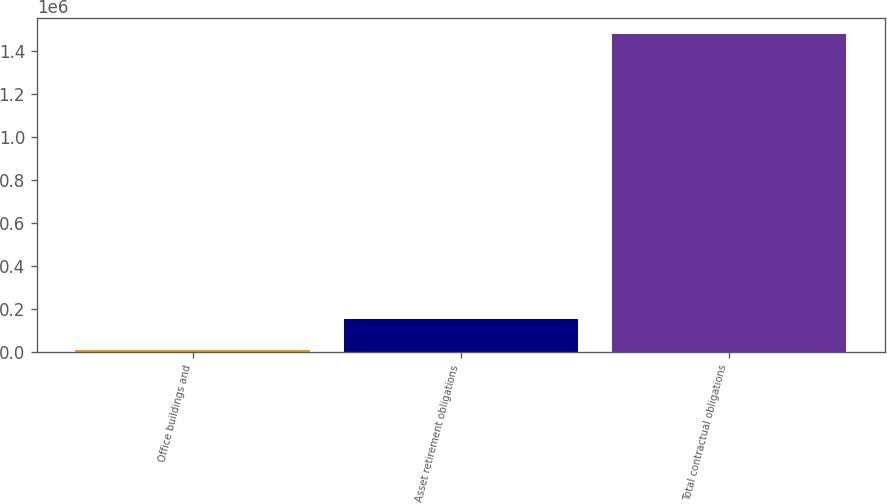Convert chart to OTSL. <chart><loc_0><loc_0><loc_500><loc_500><bar_chart><fcel>Office buildings and<fcel>Asset retirement obligations<fcel>Total contractual obligations<nl><fcel>8367<fcel>155181<fcel>1.47651e+06<nl></chart> 